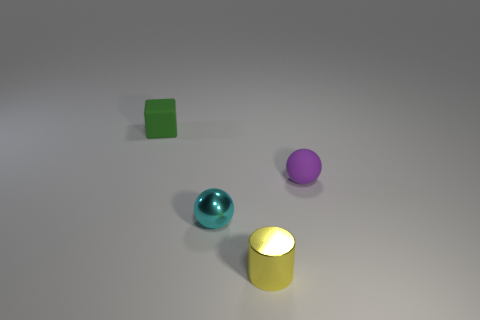There is another small object that is the same material as the green object; what shape is it?
Offer a very short reply. Sphere. Is the number of tiny yellow metal cylinders behind the green matte cube the same as the number of blocks?
Offer a terse response. No. Is the small object that is behind the small purple rubber thing made of the same material as the sphere left of the yellow metal thing?
Provide a succinct answer. No. What is the shape of the rubber thing that is to the left of the tiny sphere that is on the left side of the tiny purple matte ball?
Provide a succinct answer. Cube. What color is the small thing that is made of the same material as the small yellow cylinder?
Provide a succinct answer. Cyan. Do the tiny metallic ball and the tiny rubber block have the same color?
Your answer should be compact. No. There is a green object that is the same size as the cyan ball; what is its shape?
Provide a short and direct response. Cube. What size is the yellow thing?
Your answer should be very brief. Small. There is a rubber thing that is right of the green matte object; is its size the same as the metal object that is behind the yellow shiny cylinder?
Give a very brief answer. Yes. What is the color of the rubber object that is in front of the tiny matte object behind the tiny matte sphere?
Offer a very short reply. Purple. 